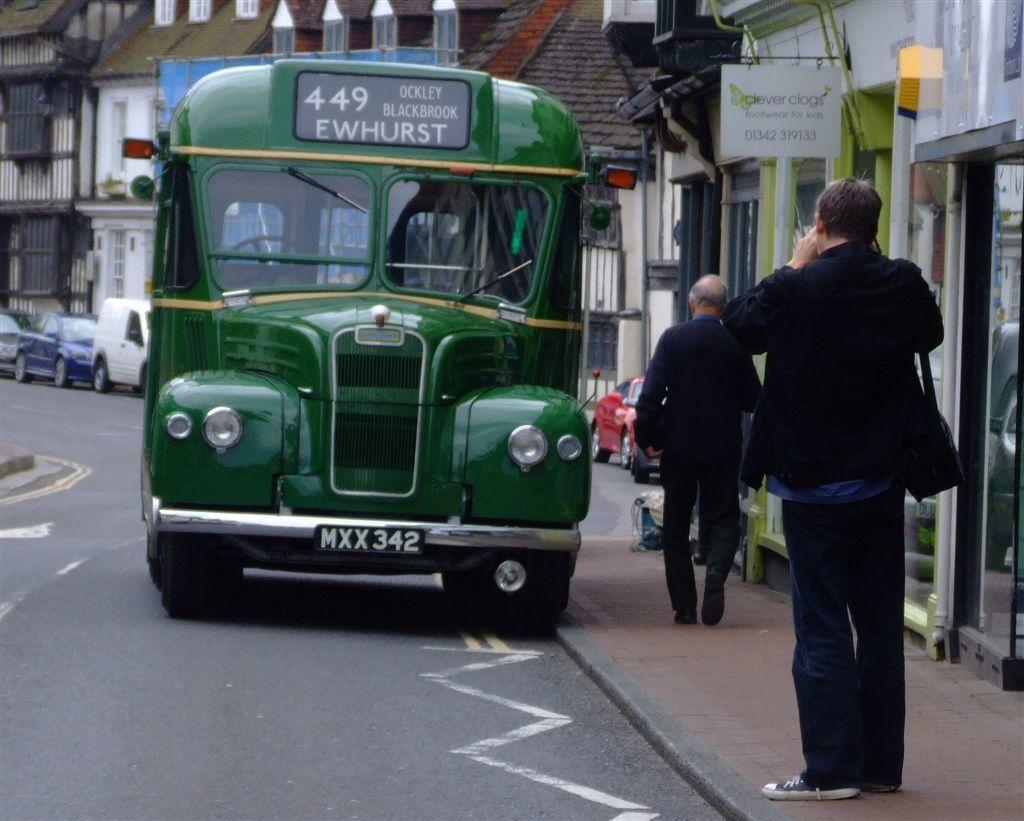Provide a one-sentence caption for the provided image. A green bus with license plate MXX 342 on a city street. 